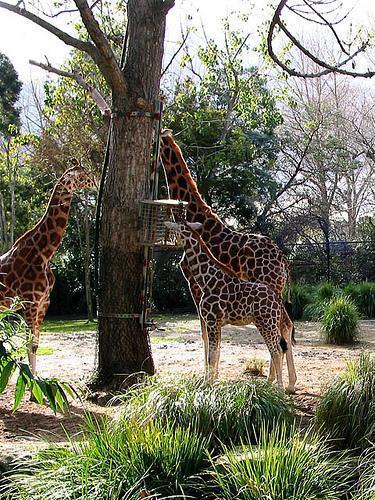How many giraffes are visible?
Give a very brief answer. 3. 